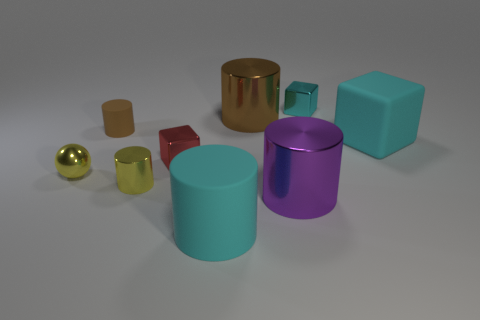How many things are either small yellow metallic objects that are to the right of the tiny yellow ball or big purple metallic cylinders?
Make the answer very short. 2. Is there a small block that is in front of the tiny shiny block that is to the right of the brown cylinder that is to the right of the brown rubber cylinder?
Provide a short and direct response. Yes. How many blue shiny objects are there?
Offer a very short reply. 0. How many objects are brown objects that are right of the small brown object or blocks that are on the right side of the big brown object?
Give a very brief answer. 3. Is the size of the metallic block that is in front of the cyan metallic block the same as the brown rubber cylinder?
Your answer should be compact. Yes. What is the size of the other rubber object that is the same shape as the tiny cyan thing?
Offer a terse response. Large. What is the material of the red cube that is the same size as the brown rubber thing?
Your answer should be compact. Metal. What is the material of the big cyan object that is the same shape as the large purple shiny object?
Offer a very short reply. Rubber. What number of other objects are there of the same size as the cyan metallic cube?
Ensure brevity in your answer.  4. The other metal cube that is the same color as the big block is what size?
Provide a succinct answer. Small. 